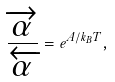<formula> <loc_0><loc_0><loc_500><loc_500>\frac { \overrightarrow { \alpha } } { \overleftarrow { \alpha } } = e ^ { A / k _ { B } T } ,</formula> 